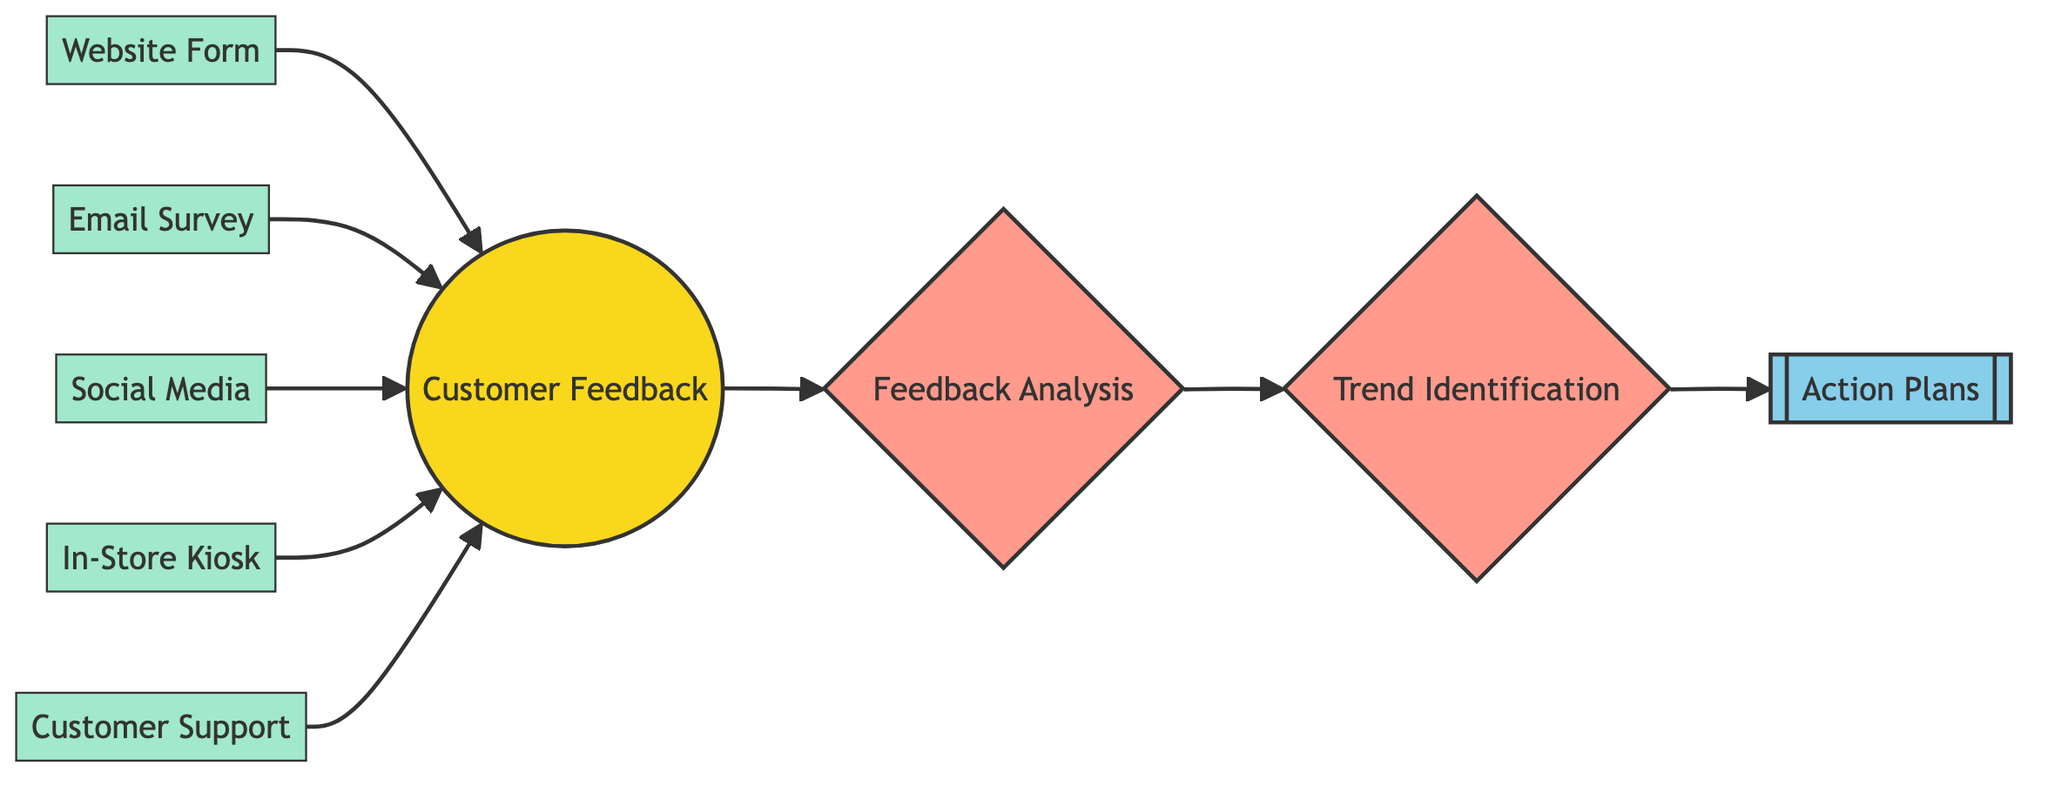What is the total number of nodes in the diagram? The diagram includes a total of ten distinct nodes, which are 'Customer Feedback', 'Website Form', 'Email Survey', 'Social Media', 'In-Store Kiosk', 'Customer Support', 'Feedback Analysis', 'Trend Identification', and 'Action Plans'.
Answer: Ten What type is the 'Customer Support' node? 'Customer Support' is classified as a feedback channel node in the diagram.
Answer: Feedback Channel How many feedback channels are present in the diagram? There are five feedback channels depicted, which are 'Website Form', 'Email Survey', 'Social Media', 'In-Store Kiosk', and 'Customer Support'.
Answer: Five Which node directly follows 'Feedback Analysis' in the flow? The 'Trend Identification' node directly follows 'Feedback Analysis', meaning that it's the next step in the process.
Answer: Trend Identification What is the last node that feedback flows into? The last node in the feedback process is 'Action Plans', which serves as the endpoint for the analysis.
Answer: Action Plans Which nodes are highlighted as processing nodes? The nodes 'Feedback Analysis' and 'Trend Identification' are both categorized as processing nodes within the network diagram.
Answer: Feedback Analysis, Trend Identification How many edges are directing towards the 'Customer Feedback' node? There are five edges directing towards the 'Customer Feedback' node, representing the variety of channels through which feedback is collected.
Answer: Five Identify the type of the 'Action Plans' node. The 'Action Plans' node is a target node, which indicates it is focused on outcomes based on feedback analysis.
Answer: Target Node What connects 'Trend Identification' to 'Action Plans'? The connection from 'Trend Identification' to 'Action Plans' represents the flow of insights that lead to actionable strategies, indicating a direct relationship between analysis outcomes and planned actions.
Answer: Edge What is the source node in this diagram? The source node in this context is 'Customer Feedback', which initiates the flow of information throughout the network.
Answer: Customer Feedback 